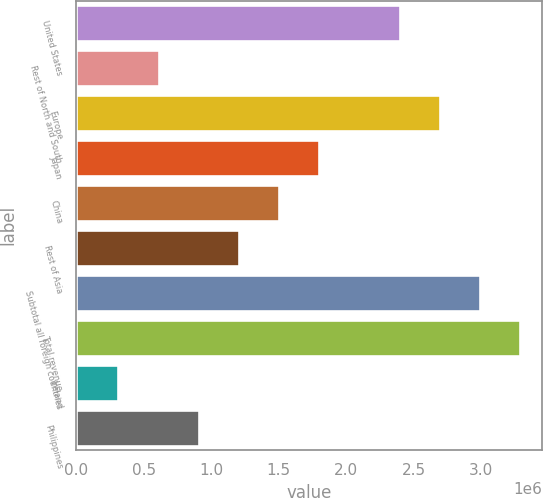<chart> <loc_0><loc_0><loc_500><loc_500><bar_chart><fcel>United States<fcel>Rest of North and South<fcel>Europe<fcel>Japan<fcel>China<fcel>Rest of Asia<fcel>Subtotal all foreign countries<fcel>Total revenue<fcel>Ireland<fcel>Philippines<nl><fcel>2.39747e+06<fcel>609918<fcel>2.69539e+06<fcel>1.80162e+06<fcel>1.50369e+06<fcel>1.20577e+06<fcel>2.99332e+06<fcel>3.29125e+06<fcel>311993<fcel>907844<nl></chart> 